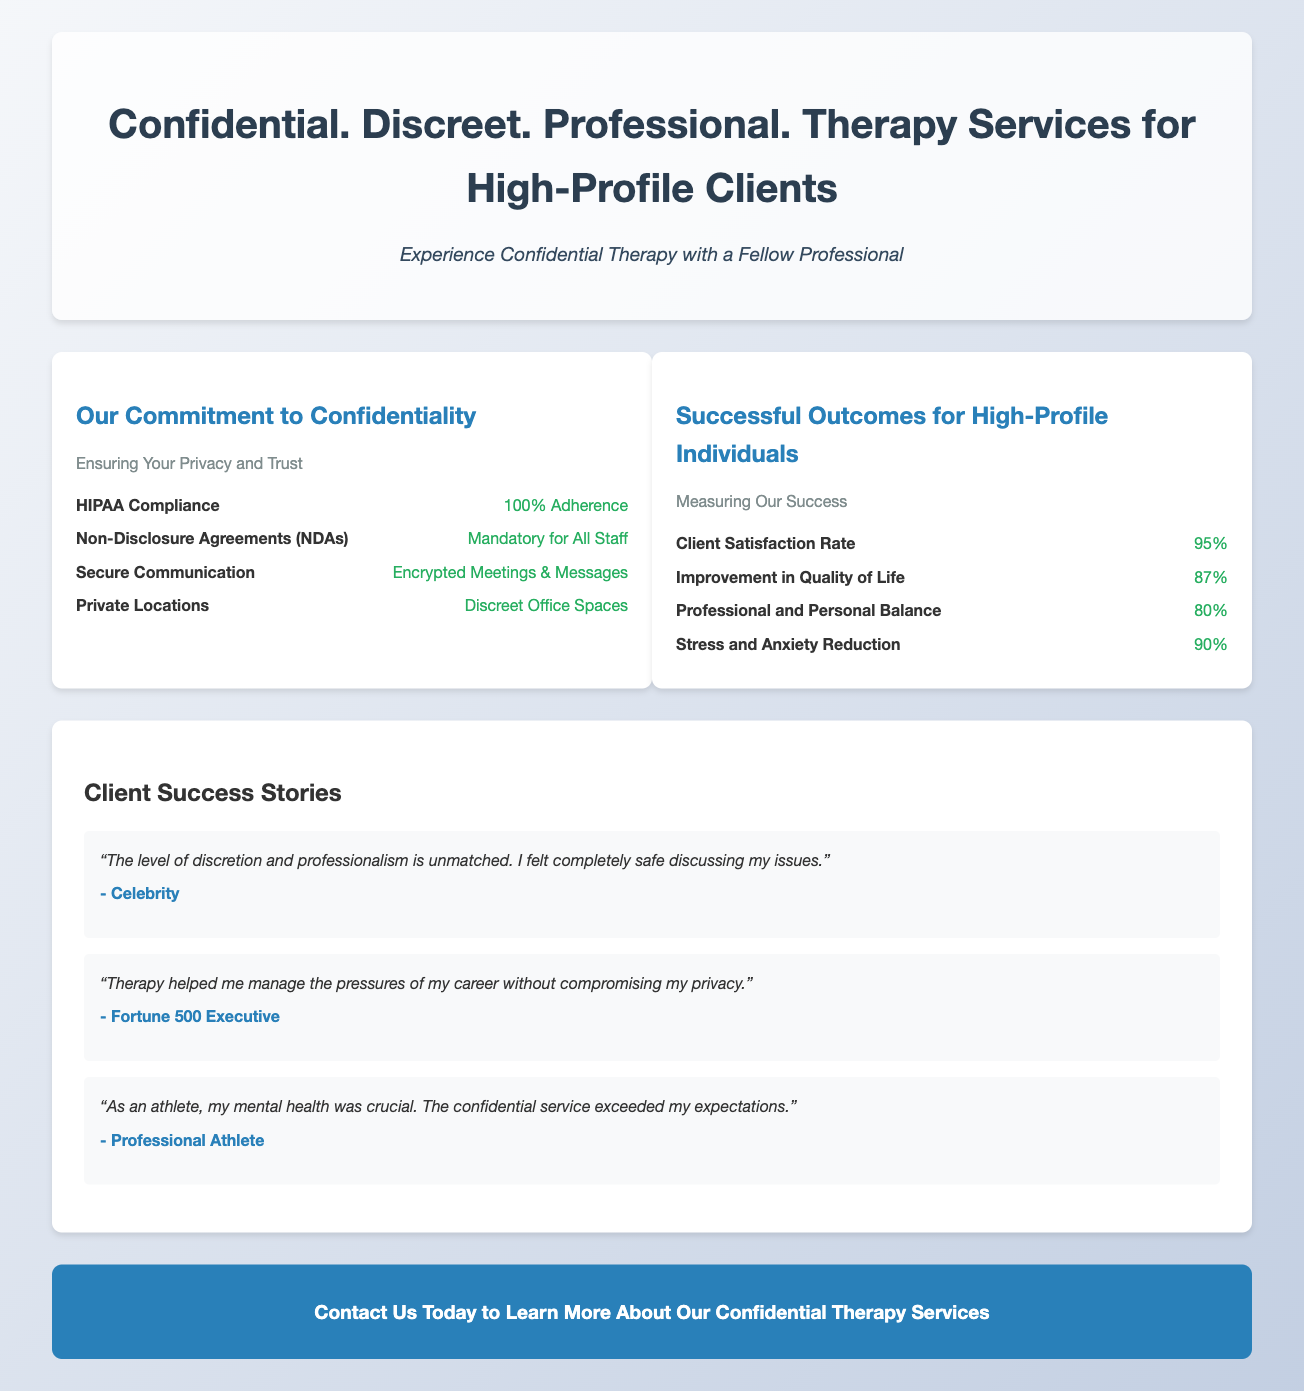What is the title of the advertisement? The title is stated at the top of the advertisement, summarizing the service provided.
Answer: Confidential. Discreet. Professional. Therapy Services for High-Profile Clients What is the client satisfaction rate? The client satisfaction rate is mentioned in the success outcomes section of the document.
Answer: 95% What type of clients does the service focus on? The focus of the service is indicated by the advertising language and testimonials.
Answer: High-Profile Clients What is the percentage of improvement in quality of life? This percentage is listed under the successful outcomes for high-profile individuals section.
Answer: 87% How is communication secured according to the document? The document specifies the method used to protect communication.
Answer: Encrypted Meetings & Messages Who provided a testimonial describing the therapy as unmatched? The type of client providing the testimonial indicates their status and perspective.
Answer: Celebrity What is the purpose of the Non-Disclosure Agreements? The purpose of NDAs is highlighted in the commitment to confidentiality section.
Answer: Mandatory for All Staff What is the background color of the call-to-action section? The background color is part of the design specifications provided in the document.
Answer: #2980b9 What is the primary focus of the infographics section? The infographics section is divided into two main areas of focus.
Answer: Confidentiality and Successful Outcomes 